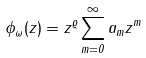<formula> <loc_0><loc_0><loc_500><loc_500>\phi _ { \omega } ( z ) = z ^ { \varrho } \sum _ { m = 0 } ^ { \infty } a _ { m } z ^ { m }</formula> 